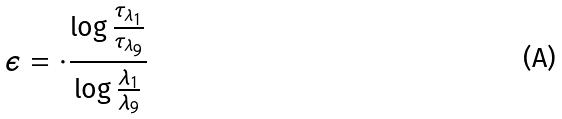Convert formula to latex. <formula><loc_0><loc_0><loc_500><loc_500>\epsilon = \cdot \frac { \log \frac { \tau _ { \lambda _ { 1 } } } { \tau _ { \lambda _ { 9 } } } } { \log \frac { \lambda _ { 1 } } { \lambda _ { 9 } } }</formula> 